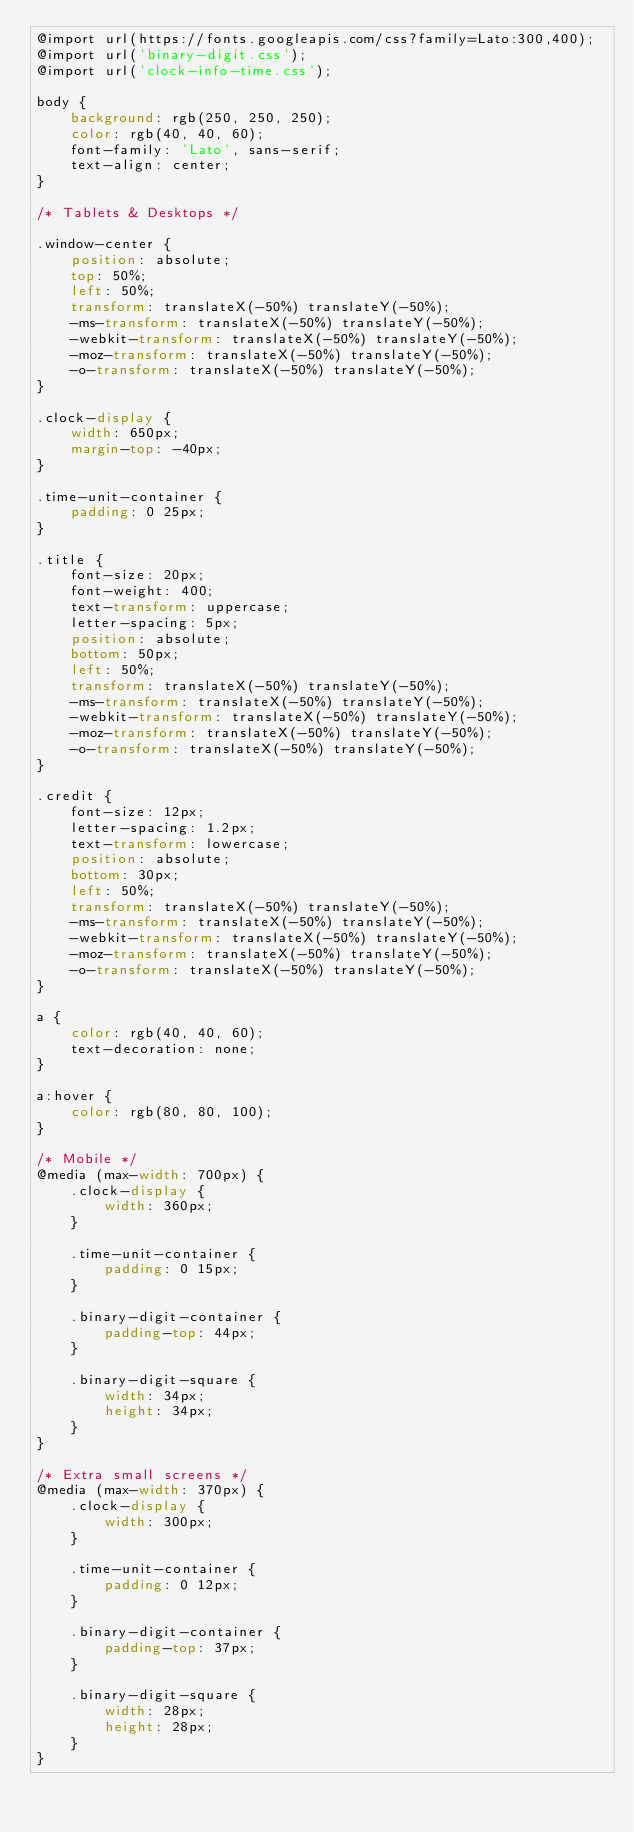<code> <loc_0><loc_0><loc_500><loc_500><_CSS_>@import url(https://fonts.googleapis.com/css?family=Lato:300,400);
@import url('binary-digit.css');
@import url('clock-info-time.css');

body {
    background: rgb(250, 250, 250);
    color: rgb(40, 40, 60);
    font-family: 'Lato', sans-serif;
    text-align: center;
}

/* Tablets & Desktops */

.window-center {
    position: absolute;
    top: 50%;
    left: 50%;
    transform: translateX(-50%) translateY(-50%);
    -ms-transform: translateX(-50%) translateY(-50%);
    -webkit-transform: translateX(-50%) translateY(-50%);
    -moz-transform: translateX(-50%) translateY(-50%);
    -o-transform: translateX(-50%) translateY(-50%);
}

.clock-display {
    width: 650px;
    margin-top: -40px;
}

.time-unit-container {
    padding: 0 25px;
}

.title {
    font-size: 20px;
    font-weight: 400;
    text-transform: uppercase;
    letter-spacing: 5px;
    position: absolute;
    bottom: 50px;
    left: 50%;
    transform: translateX(-50%) translateY(-50%);
    -ms-transform: translateX(-50%) translateY(-50%);
    -webkit-transform: translateX(-50%) translateY(-50%);
    -moz-transform: translateX(-50%) translateY(-50%);
    -o-transform: translateX(-50%) translateY(-50%);
}

.credit {
    font-size: 12px;
    letter-spacing: 1.2px;
    text-transform: lowercase;
    position: absolute;
    bottom: 30px;
    left: 50%;
    transform: translateX(-50%) translateY(-50%);
    -ms-transform: translateX(-50%) translateY(-50%);
    -webkit-transform: translateX(-50%) translateY(-50%);
    -moz-transform: translateX(-50%) translateY(-50%);
    -o-transform: translateX(-50%) translateY(-50%);
}

a {
    color: rgb(40, 40, 60);
    text-decoration: none;
}

a:hover {
    color: rgb(80, 80, 100);
}

/* Mobile */
@media (max-width: 700px) {
    .clock-display {
        width: 360px;
    }

    .time-unit-container {
        padding: 0 15px;
    }

    .binary-digit-container {
        padding-top: 44px;
    }

    .binary-digit-square {
        width: 34px;
        height: 34px;
    }
}

/* Extra small screens */ 
@media (max-width: 370px) {
    .clock-display {
        width: 300px;
    }

    .time-unit-container {
        padding: 0 12px;
    }

    .binary-digit-container {
        padding-top: 37px;
    }

    .binary-digit-square {
        width: 28px;
        height: 28px;
    }
}
</code> 